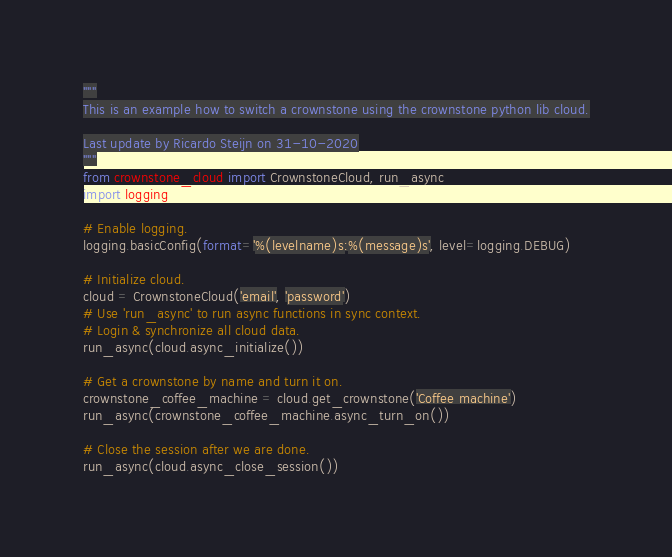Convert code to text. <code><loc_0><loc_0><loc_500><loc_500><_Python_>"""
This is an example how to switch a crownstone using the crownstone python lib cloud.

Last update by Ricardo Steijn on 31-10-2020
"""
from crownstone_cloud import CrownstoneCloud, run_async
import logging

# Enable logging.
logging.basicConfig(format='%(levelname)s:%(message)s', level=logging.DEBUG)

# Initialize cloud.
cloud = CrownstoneCloud('email', 'password')
# Use 'run_async' to run async functions in sync context.
# Login & synchronize all cloud data.
run_async(cloud.async_initialize())

# Get a crownstone by name and turn it on.
crownstone_coffee_machine = cloud.get_crownstone('Coffee machine')
run_async(crownstone_coffee_machine.async_turn_on())

# Close the session after we are done.
run_async(cloud.async_close_session())
</code> 